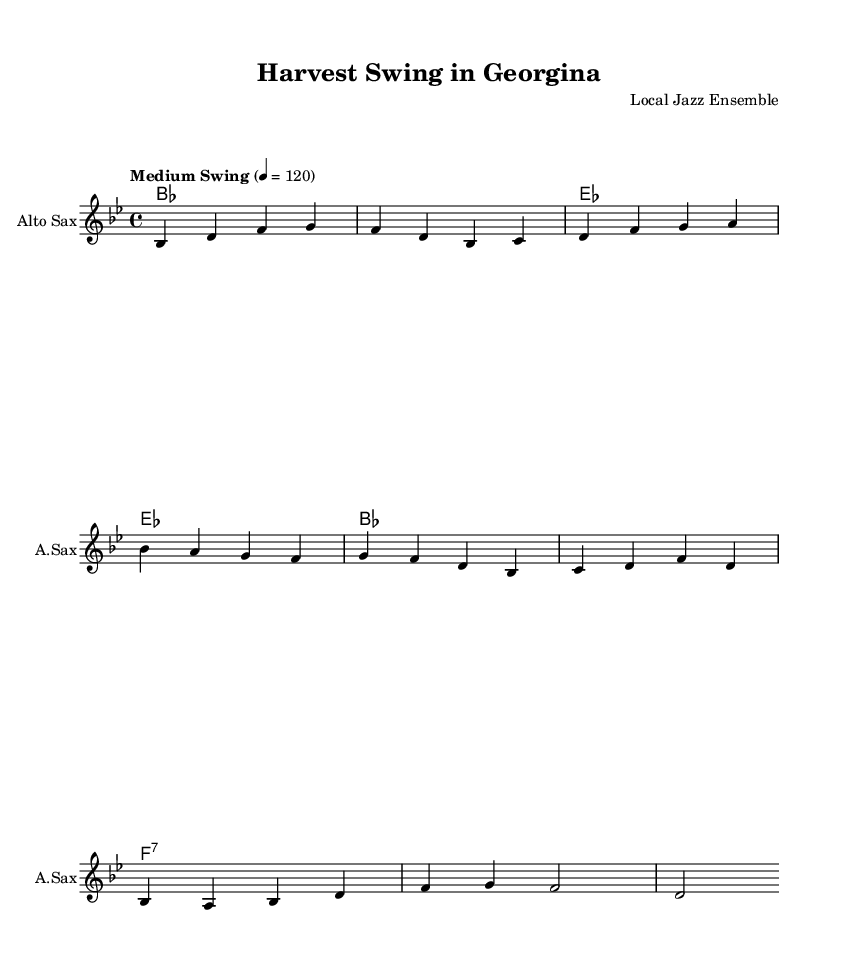What is the key signature of this music? The key signature is B flat major, which has two flats (B flat and E flat). This can be identified in the sheet music at the beginning, where the flats are indicated.
Answer: B flat major What is the time signature of this music? The time signature is 4/4, which means there are four beats in each measure and the quarter note gets one beat. This is located at the beginning of the score, typically right after the key signature.
Answer: 4/4 What is the tempo marking for this piece? The tempo marking is "Medium Swing," indicated near the top of the sheet music. This gives performers guidance on how to interpret the feel of the piece.
Answer: Medium Swing How many measures are in the melody section? There are eight measures in the melody section. This can be determined by counting the groupings of notes and their respective bars on the staff.
Answer: 8 What type of chords are used in the harmonies section? The harmonies include major and seventh chords. This is evident from the chord symbols written above the staff, which show the root note and type of chord.
Answer: Major and seventh chords Which instrument is notated in the staff? The instrument notated in the staff is the Alto Saxophone. This is indicated by the label on the staff which specifies the instrument's name.
Answer: Alto Sax What does the lyric in the first measure celebrate? The lyric in the first measure celebrates the agricultural heritage of Georgina. This is evident as the first line talks about fields and is contextually about farming, which is aligned with the heritage theme.
Answer: Agricultural heritage 